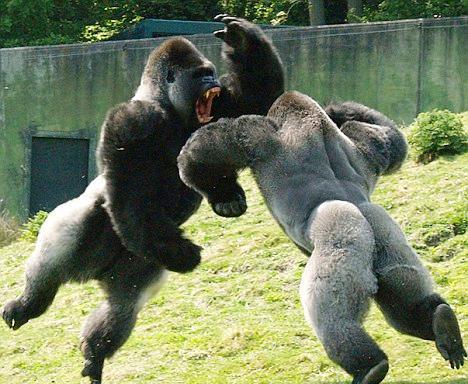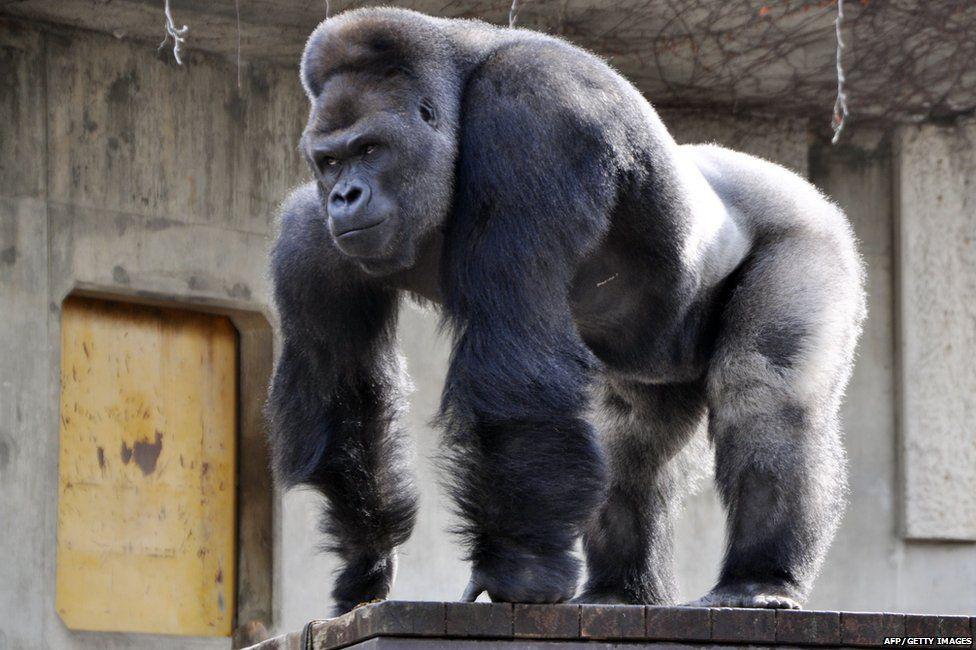The first image is the image on the left, the second image is the image on the right. Analyze the images presented: Is the assertion "One of the images contains two gorillas that are fighting." valid? Answer yes or no. Yes. 